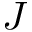<formula> <loc_0><loc_0><loc_500><loc_500>J</formula> 